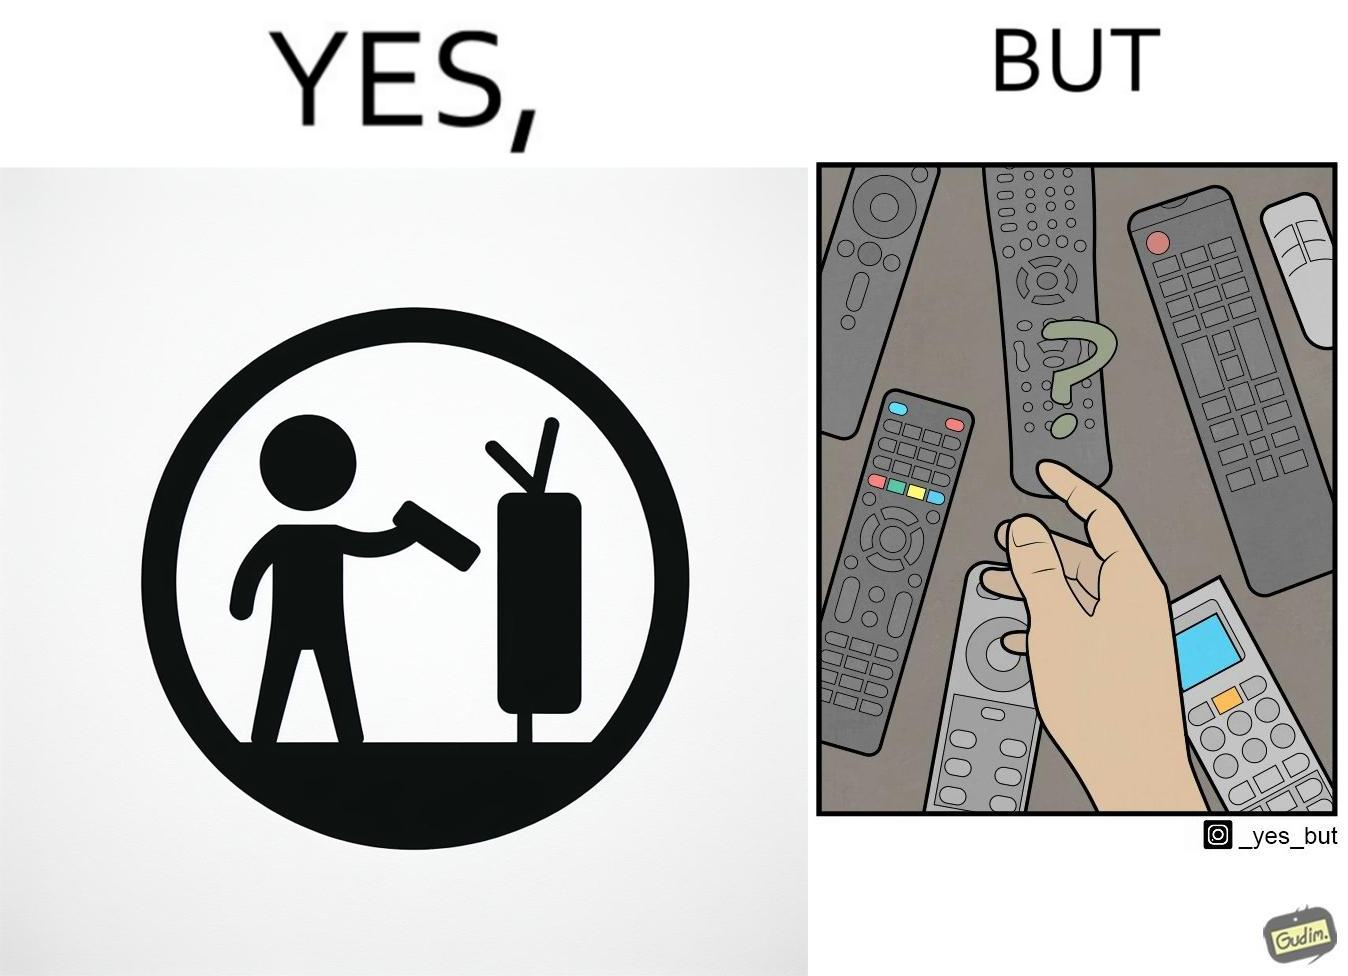What is shown in this image? The images are funny since they show how even though TV remotes are supposed to make operating TVs easier, having multiple similar looking remotes  for everything only makes it more difficult for the user to use the right one 